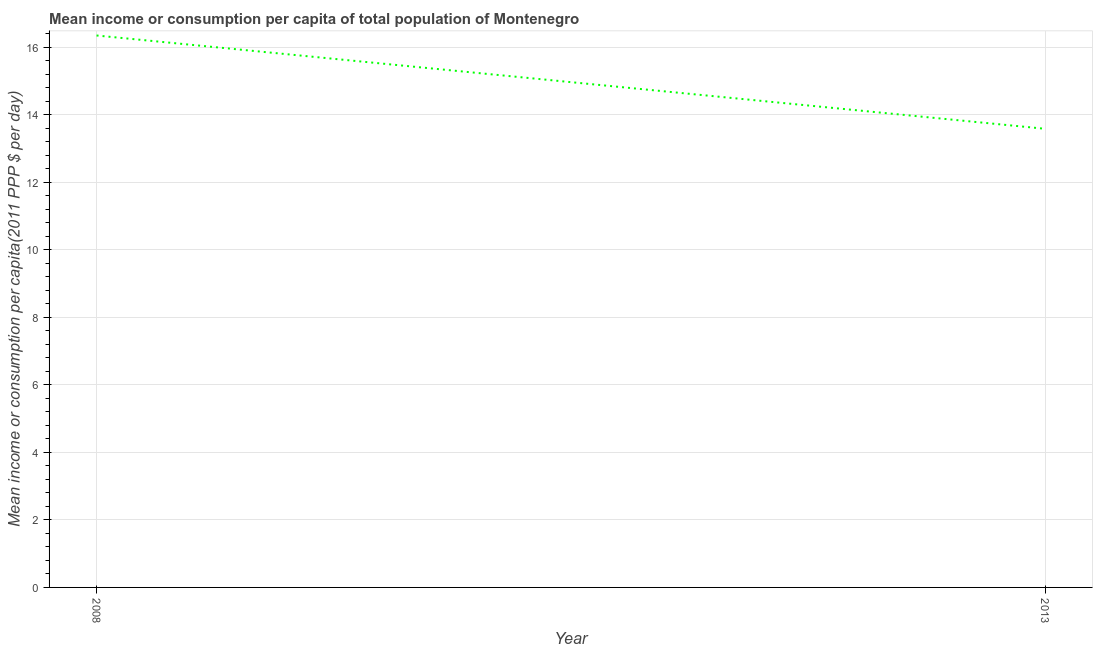What is the mean income or consumption in 2013?
Your answer should be very brief. 13.59. Across all years, what is the maximum mean income or consumption?
Keep it short and to the point. 16.35. Across all years, what is the minimum mean income or consumption?
Your response must be concise. 13.59. What is the sum of the mean income or consumption?
Offer a very short reply. 29.94. What is the difference between the mean income or consumption in 2008 and 2013?
Your answer should be very brief. 2.76. What is the average mean income or consumption per year?
Your answer should be compact. 14.97. What is the median mean income or consumption?
Offer a very short reply. 14.97. What is the ratio of the mean income or consumption in 2008 to that in 2013?
Your answer should be compact. 1.2. Is the mean income or consumption in 2008 less than that in 2013?
Ensure brevity in your answer.  No. How many years are there in the graph?
Provide a succinct answer. 2. What is the difference between two consecutive major ticks on the Y-axis?
Make the answer very short. 2. Are the values on the major ticks of Y-axis written in scientific E-notation?
Keep it short and to the point. No. Does the graph contain grids?
Ensure brevity in your answer.  Yes. What is the title of the graph?
Ensure brevity in your answer.  Mean income or consumption per capita of total population of Montenegro. What is the label or title of the Y-axis?
Provide a succinct answer. Mean income or consumption per capita(2011 PPP $ per day). What is the Mean income or consumption per capita(2011 PPP $ per day) in 2008?
Offer a very short reply. 16.35. What is the Mean income or consumption per capita(2011 PPP $ per day) in 2013?
Your response must be concise. 13.59. What is the difference between the Mean income or consumption per capita(2011 PPP $ per day) in 2008 and 2013?
Ensure brevity in your answer.  2.76. What is the ratio of the Mean income or consumption per capita(2011 PPP $ per day) in 2008 to that in 2013?
Offer a terse response. 1.2. 